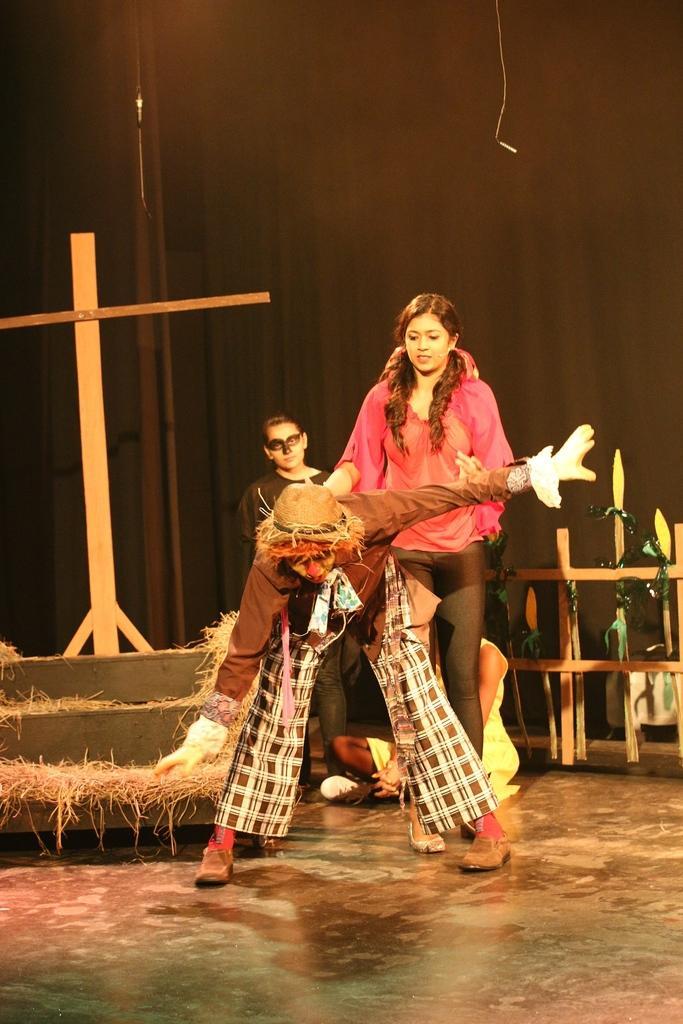In one or two sentences, can you explain what this image depicts? In this picture I can observe some people on the floor. On the right side I can observe a woman standing on the floor, wearing pink color dress. On the left side I can observe some dried grass. In the background I can observe a curtain. 